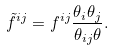<formula> <loc_0><loc_0><loc_500><loc_500>\tilde { f } ^ { i j } = f ^ { i j } \frac { \theta _ { i } \theta _ { j } } { \theta _ { i j } \theta } .</formula> 